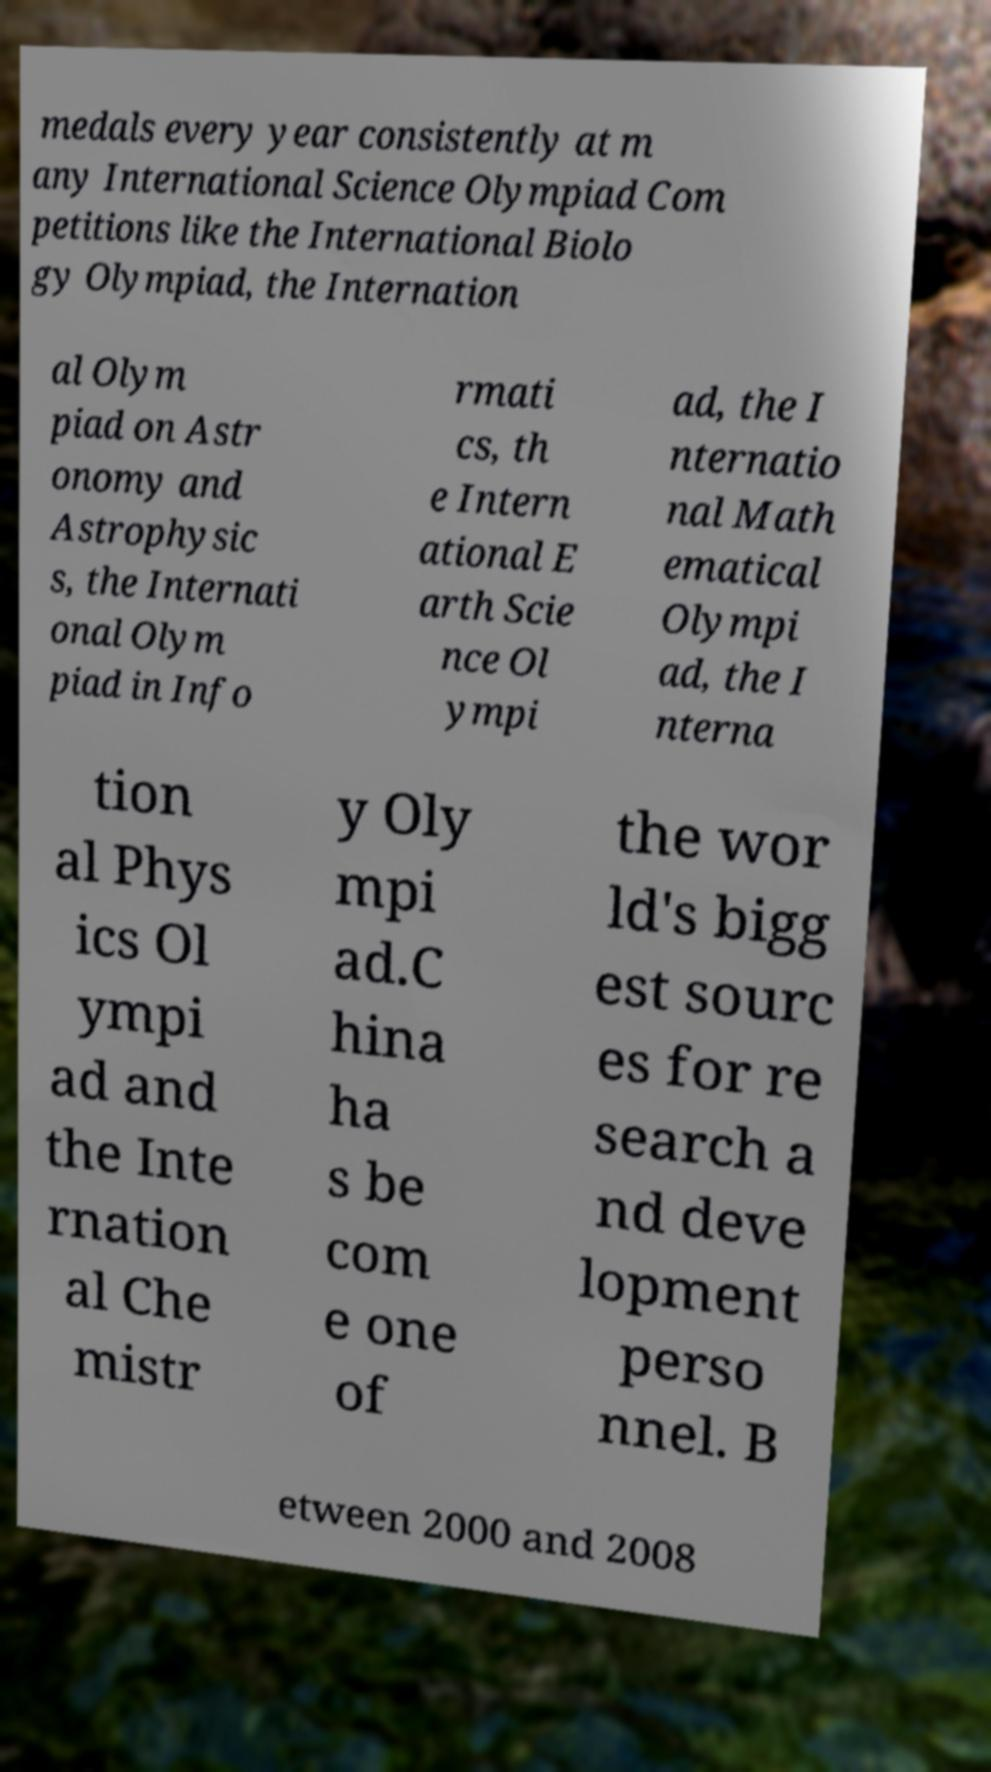Can you accurately transcribe the text from the provided image for me? medals every year consistently at m any International Science Olympiad Com petitions like the International Biolo gy Olympiad, the Internation al Olym piad on Astr onomy and Astrophysic s, the Internati onal Olym piad in Info rmati cs, th e Intern ational E arth Scie nce Ol ympi ad, the I nternatio nal Math ematical Olympi ad, the I nterna tion al Phys ics Ol ympi ad and the Inte rnation al Che mistr y Oly mpi ad.C hina ha s be com e one of the wor ld's bigg est sourc es for re search a nd deve lopment perso nnel. B etween 2000 and 2008 